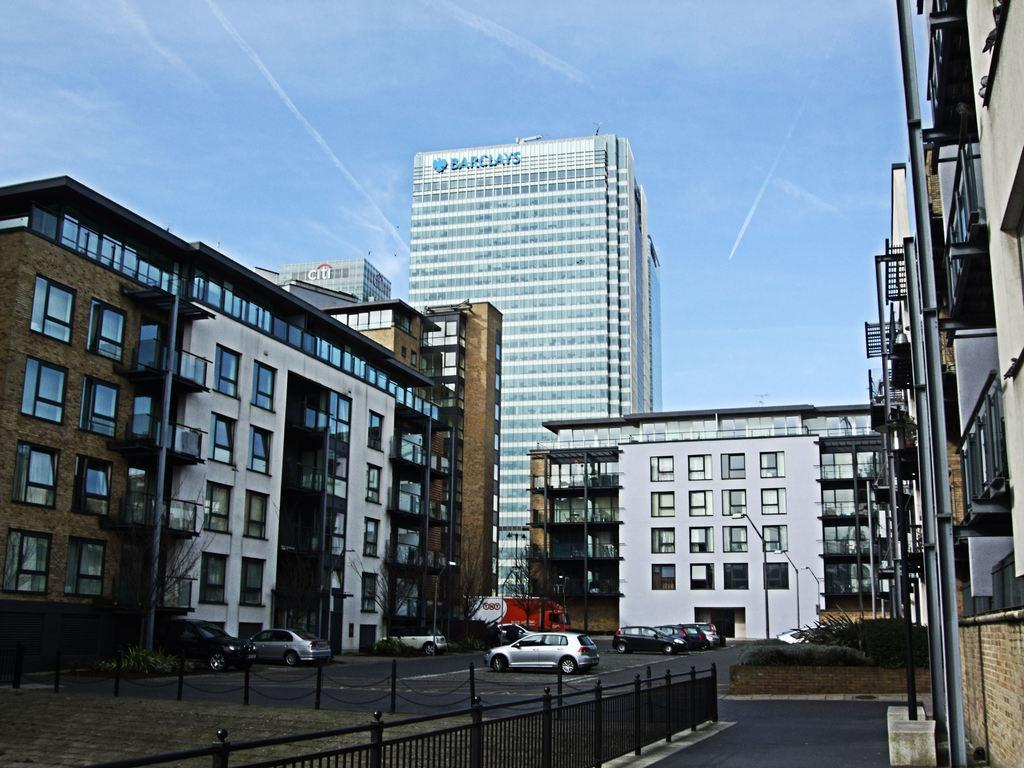What can be seen on the road in the image? There are vehicles on the road in the image. What structures are present in the image? There are poles, a fence, buildings with windows, and street light poles in the image. What type of vegetation is visible in the image? There are trees and plants in the image. What is visible in the background of the image? The sky is visible in the background of the image. Can you see an argument taking place between the vehicles in the image? There is no argument present in the image; it only shows vehicles on the road. Where are the scissors located in the image? There are no scissors present in the image. 